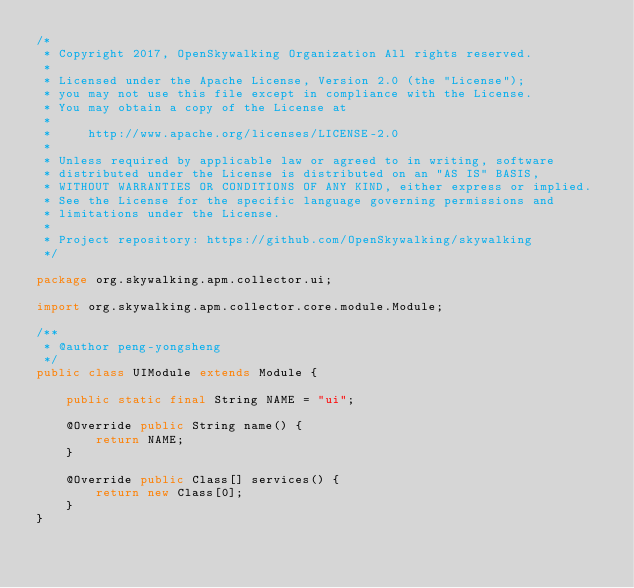<code> <loc_0><loc_0><loc_500><loc_500><_Java_>/*
 * Copyright 2017, OpenSkywalking Organization All rights reserved.
 *
 * Licensed under the Apache License, Version 2.0 (the "License");
 * you may not use this file except in compliance with the License.
 * You may obtain a copy of the License at
 *
 *     http://www.apache.org/licenses/LICENSE-2.0
 *
 * Unless required by applicable law or agreed to in writing, software
 * distributed under the License is distributed on an "AS IS" BASIS,
 * WITHOUT WARRANTIES OR CONDITIONS OF ANY KIND, either express or implied.
 * See the License for the specific language governing permissions and
 * limitations under the License.
 *
 * Project repository: https://github.com/OpenSkywalking/skywalking
 */

package org.skywalking.apm.collector.ui;

import org.skywalking.apm.collector.core.module.Module;

/**
 * @author peng-yongsheng
 */
public class UIModule extends Module {

    public static final String NAME = "ui";

    @Override public String name() {
        return NAME;
    }

    @Override public Class[] services() {
        return new Class[0];
    }
}
</code> 